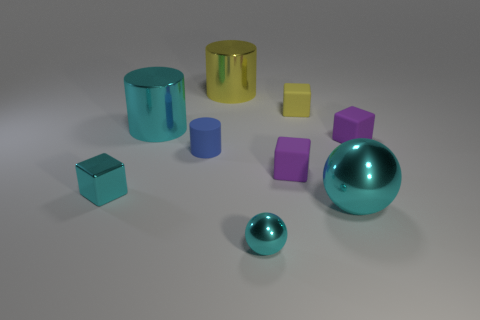How many cyan balls must be subtracted to get 1 cyan balls? 1 Subtract all blocks. How many objects are left? 5 Add 1 large cyan things. How many objects exist? 10 Subtract all purple cubes. How many cubes are left? 2 Subtract all large metal cylinders. How many cylinders are left? 1 Subtract 2 balls. How many balls are left? 0 Subtract all cyan cylinders. Subtract all red blocks. How many cylinders are left? 2 Subtract all cyan cylinders. How many purple blocks are left? 2 Subtract all cyan shiny cylinders. Subtract all large green rubber blocks. How many objects are left? 8 Add 4 cyan blocks. How many cyan blocks are left? 5 